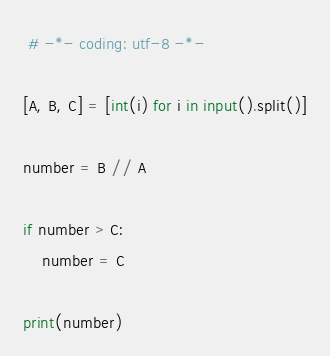<code> <loc_0><loc_0><loc_500><loc_500><_Python_> # -*- coding: utf-8 -*-
     
[A, B, C] = [int(i) for i in input().split()]

number = B // A

if number > C:
    number = C

print(number)
</code> 